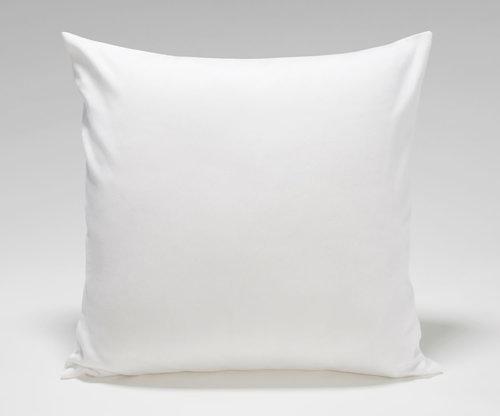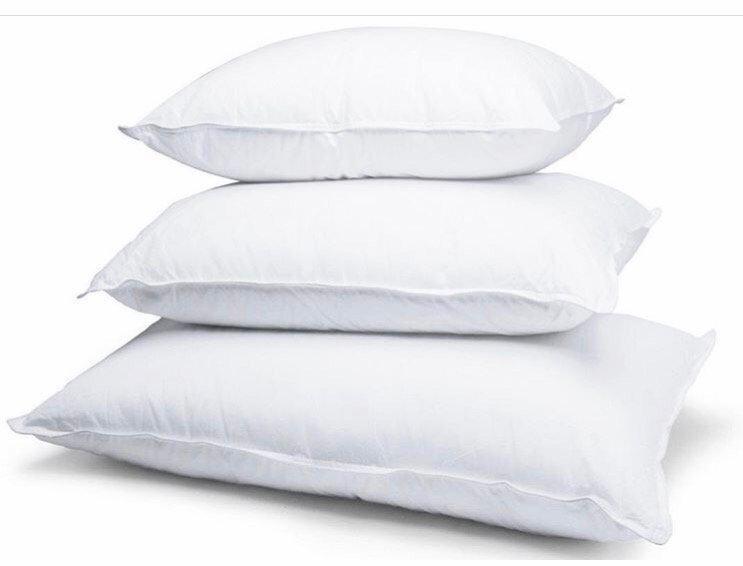The first image is the image on the left, the second image is the image on the right. For the images shown, is this caption "One of the images has fewer than two pillows." true? Answer yes or no. Yes. The first image is the image on the left, the second image is the image on the right. Examine the images to the left and right. Is the description "Each image contains two pillows, and all pillows are rectangular rather than square." accurate? Answer yes or no. No. 